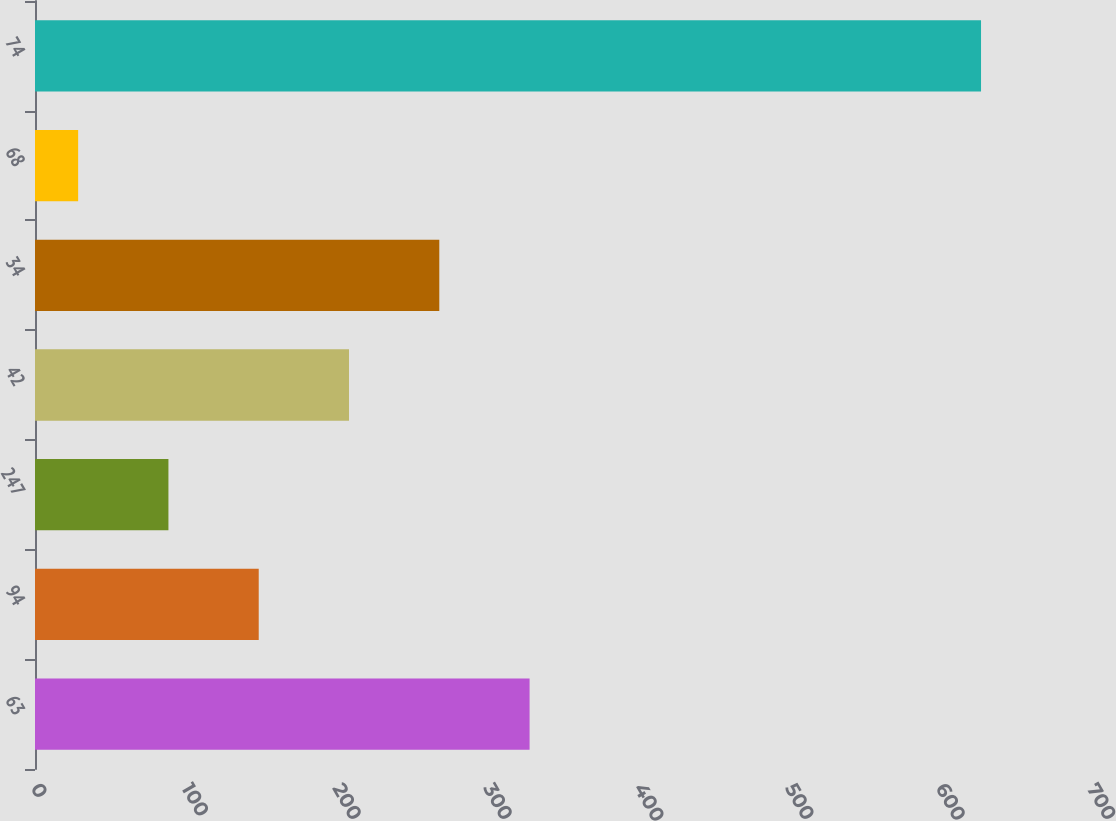Convert chart. <chart><loc_0><loc_0><loc_500><loc_500><bar_chart><fcel>63<fcel>94<fcel>247<fcel>42<fcel>34<fcel>68<fcel>74<nl><fcel>327.85<fcel>148.3<fcel>88.45<fcel>208.15<fcel>268<fcel>28.6<fcel>627.1<nl></chart> 